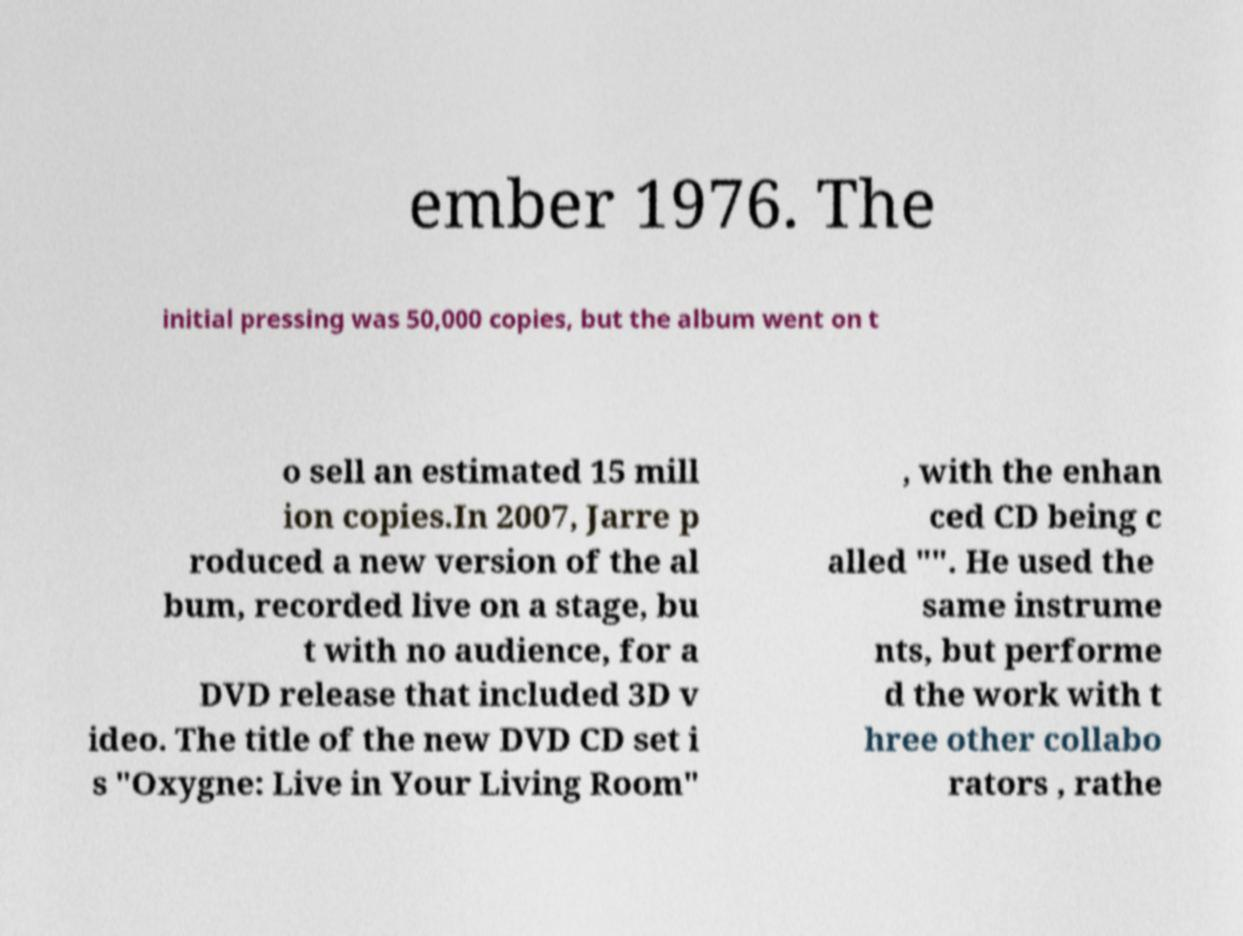Please identify and transcribe the text found in this image. ember 1976. The initial pressing was 50,000 copies, but the album went on t o sell an estimated 15 mill ion copies.In 2007, Jarre p roduced a new version of the al bum, recorded live on a stage, bu t with no audience, for a DVD release that included 3D v ideo. The title of the new DVD CD set i s "Oxygne: Live in Your Living Room" , with the enhan ced CD being c alled "". He used the same instrume nts, but performe d the work with t hree other collabo rators , rathe 